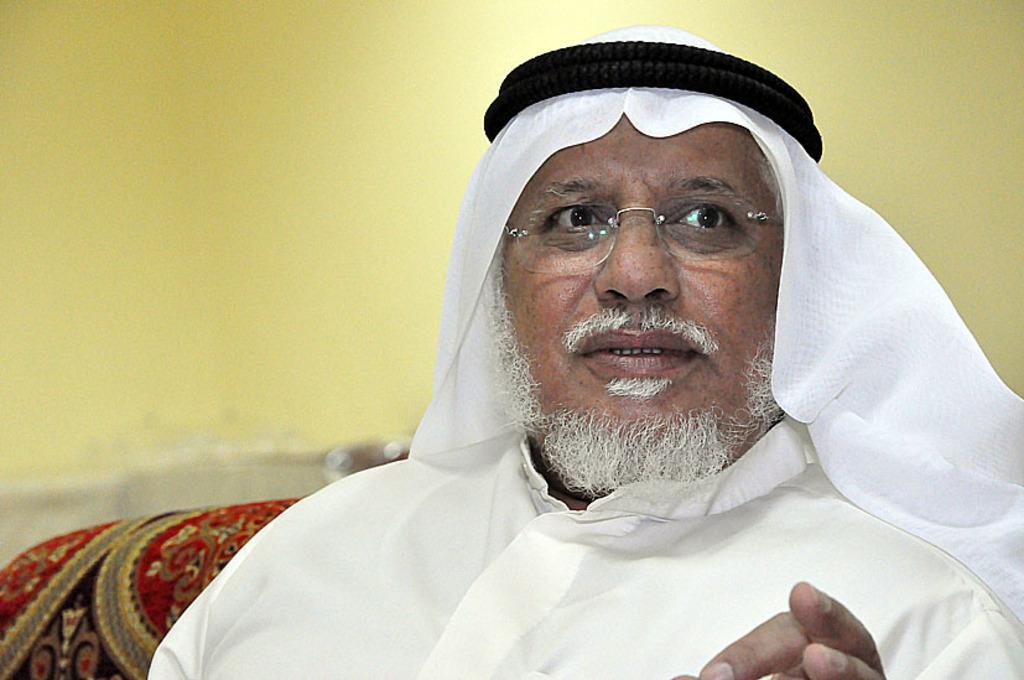Describe this image in one or two sentences. In the foreground of the image there is a person wearing white color dress, sitting on a couch. In the background of the image there is wall. 